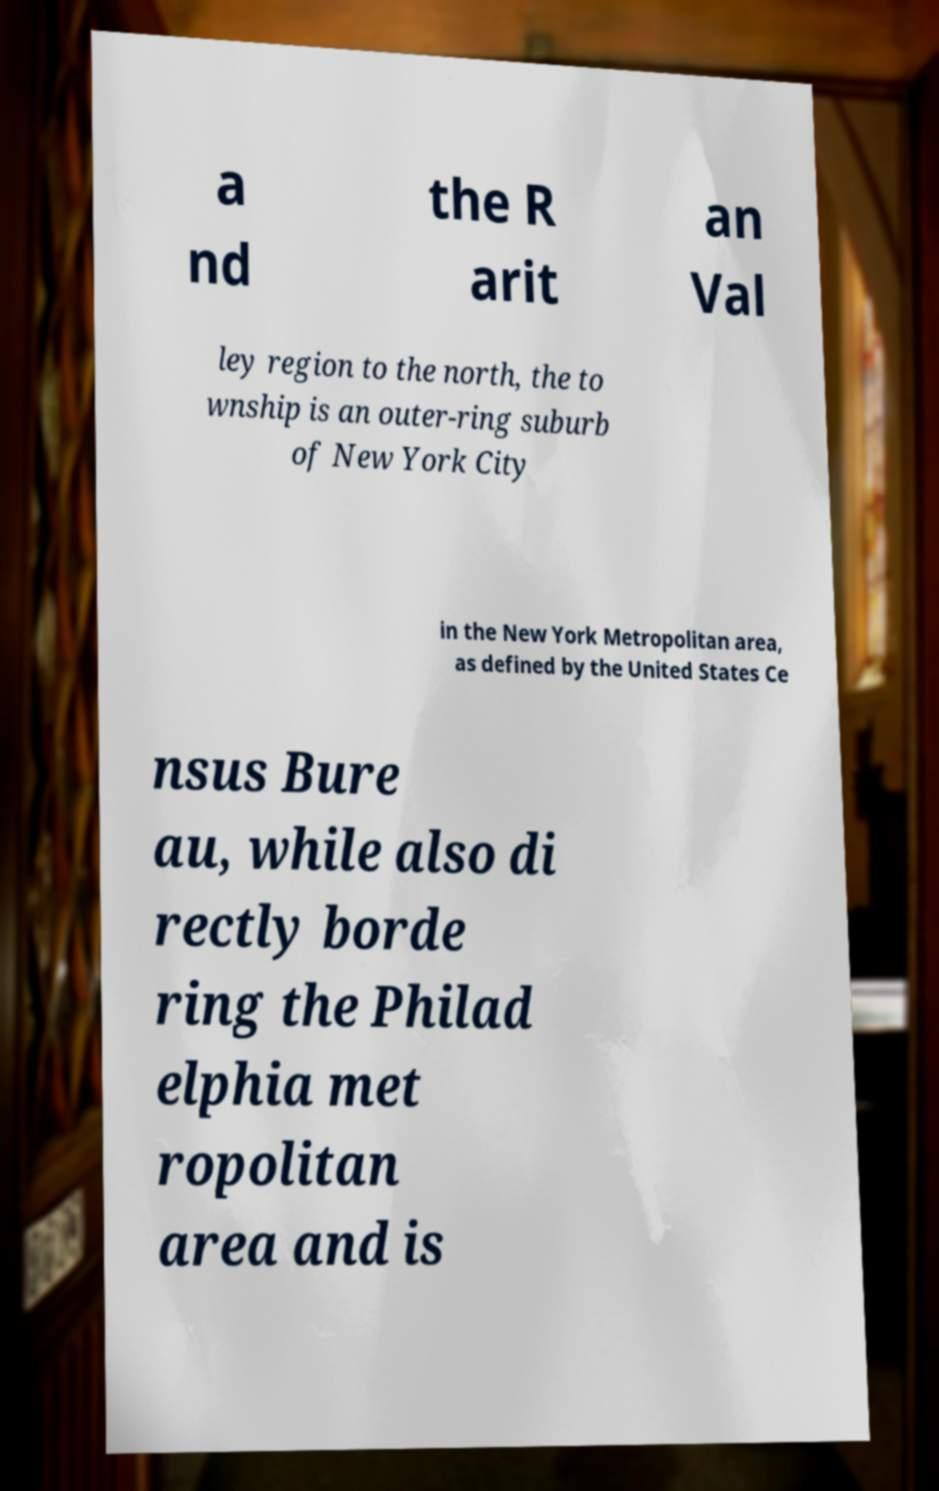I need the written content from this picture converted into text. Can you do that? a nd the R arit an Val ley region to the north, the to wnship is an outer-ring suburb of New York City in the New York Metropolitan area, as defined by the United States Ce nsus Bure au, while also di rectly borde ring the Philad elphia met ropolitan area and is 